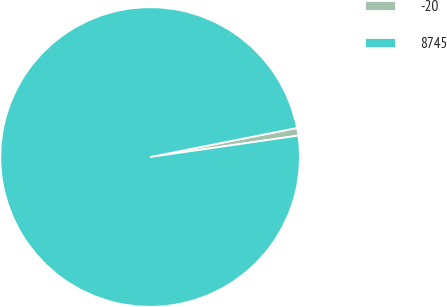Convert chart to OTSL. <chart><loc_0><loc_0><loc_500><loc_500><pie_chart><fcel>-20<fcel>8745<nl><fcel>0.82%<fcel>99.18%<nl></chart> 